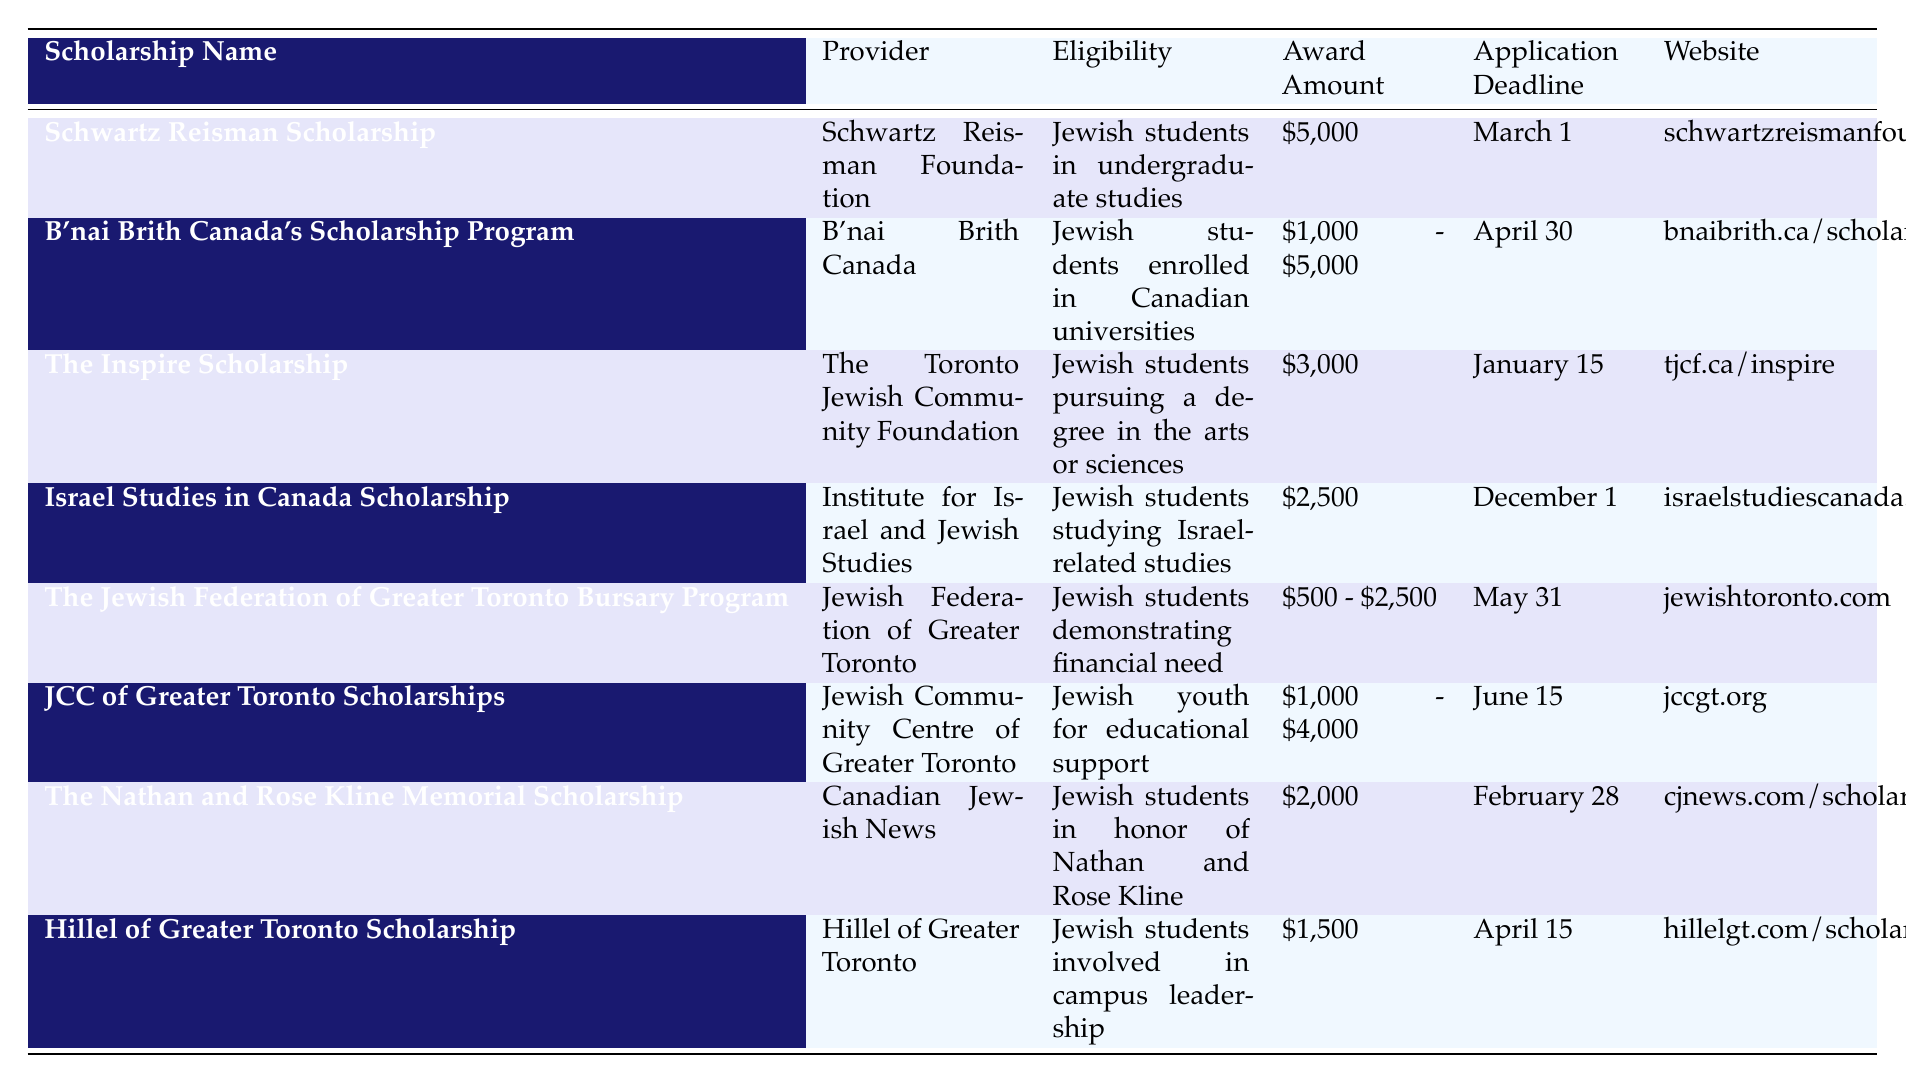What is the highest award amount available for a scholarship? The highest award amount listed in the table is $5,000, which is for the Schwartz Reisman Scholarship.
Answer: $5,000 Which scholarship has an application deadline in February? The Nathan and Rose Kline Memorial Scholarship has an application deadline of February 28.
Answer: Nathan and Rose Kline Memorial Scholarship What is the eligibility requirement for the Inspire Scholarship? The Inspire Scholarship is available for Jewish students pursuing a degree in the arts or sciences.
Answer: Jewish students pursuing a degree in the arts or sciences Is there any scholarship that requires demonstrating financial need? Yes, the Jewish Federation of Greater Toronto Bursary Program requires demonstrating financial need.
Answer: Yes How many scholarships provide an award amount between $1,000 and $4,000? Three scholarships fall within that range: B'nai Brith Canada's Scholarship Program, JCC of Greater Toronto Scholarships, and The Jewish Federation of Greater Toronto Bursary Program.
Answer: 3 What is the average award amount for scholarships provided by the Jewish Community Centre of Greater Toronto? The award amount for the JCC of Greater Toronto Scholarships is between $1,000 and $4,000, which means the average can be calculated as ($1,000 + $4,000) / 2 = $2,500.
Answer: $2,500 Which scholarship is specifically for students studying Israel-related studies and what is its award amount? The Israel Studies in Canada Scholarship is for students studying Israel-related studies and offers an award amount of $2,500.
Answer: $2,500 What is the total possible award amount if a student receives both the Hillel of Greater Toronto Scholarship and the Inspire Scholarship? The Hillel of Greater Toronto Scholarship provides $1,500, and the Inspire Scholarship provides $3,000. Therefore, the total possible award amount is $1,500 + $3,000 = $4,500.
Answer: $4,500 Who provides the Schwartz Reisman Scholarship? The Schwartz Reisman Scholarship is provided by the Schwartz Reisman Foundation.
Answer: Schwartz Reisman Foundation What is the earliest application deadline listed in the table? The earliest application deadline is January 15 for The Inspire Scholarship.
Answer: January 15 